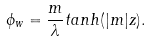<formula> <loc_0><loc_0><loc_500><loc_500>\phi _ { w } = \frac { m } { \lambda } t a n h ( | m | z ) .</formula> 